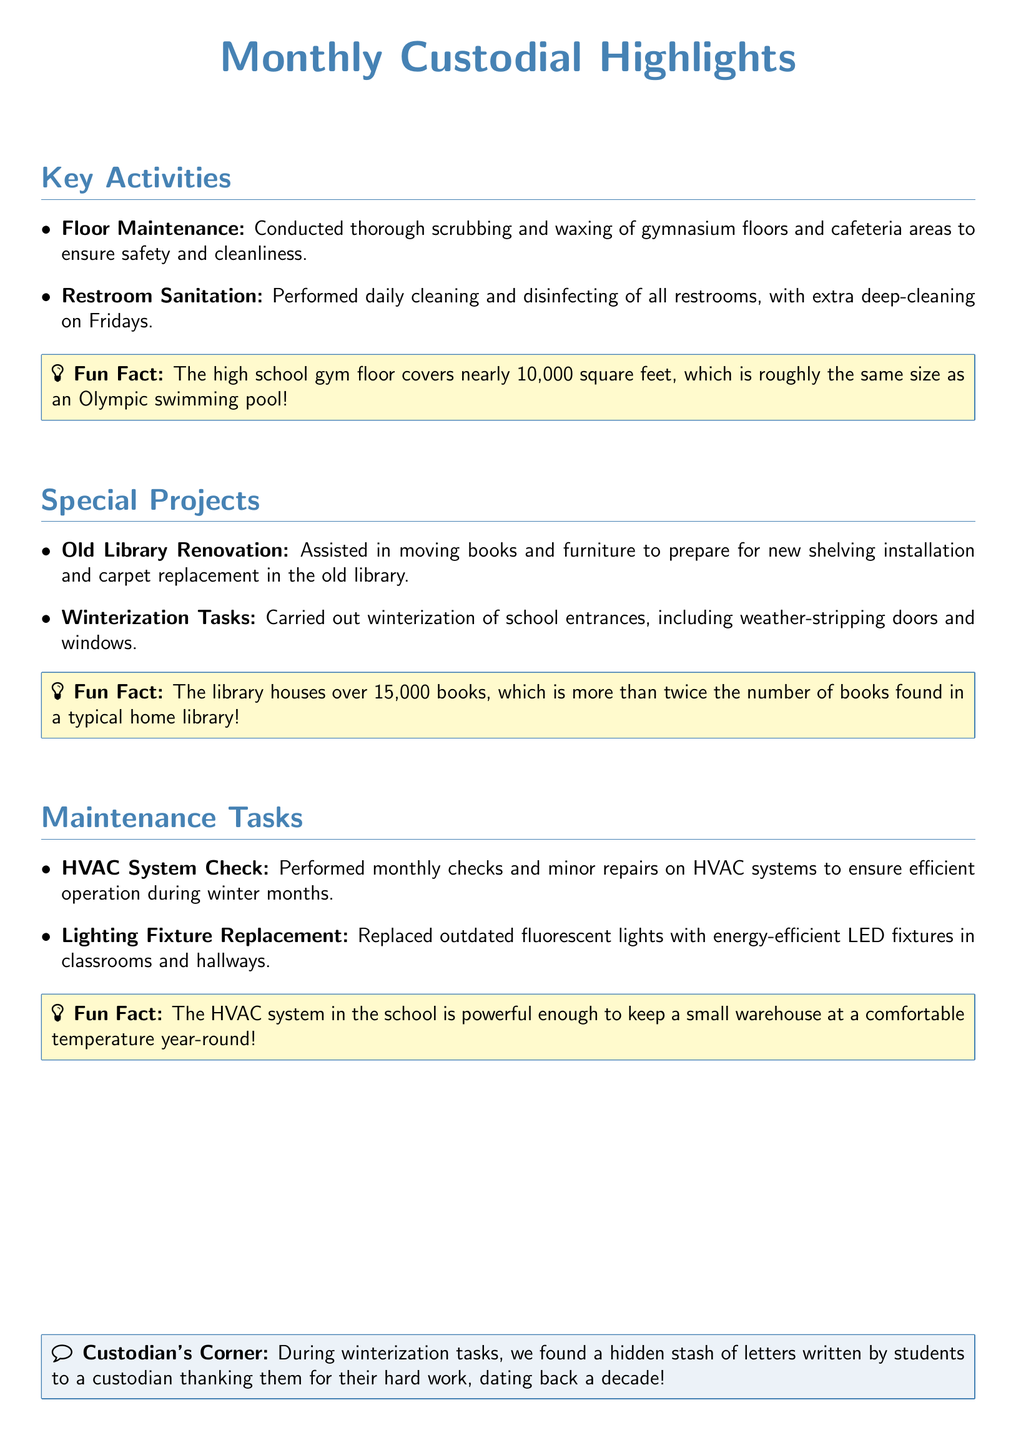What activity involves thorough scrubbing and waxing? The document mentions "Floor Maintenance" as an activity that includes thorough scrubbing and waxing of gymnasium floors and cafeteria areas.
Answer: Floor Maintenance How many square feet does the gym floor cover? The document states that the gym floor covers nearly 10,000 square feet.
Answer: 10,000 square feet What special project involved moving books? The "Old Library Renovation" is the special project that involved moving books and furniture to prepare for renovations.
Answer: Old Library Renovation How many books does the library house? The document indicates that the library houses over 15,000 books.
Answer: 15,000 books What system was checked for maintenance tasks? The HVAC System was checked as part of the maintenance tasks performed.
Answer: HVAC System What was replaced in classrooms and hallways? The document mentions that lighting fixtures were replaced with energy-efficient LED fixtures.
Answer: Lighting Fixture Replacement What did custodians find during winterization tasks? A hidden stash of letters written by students to a custodian was discovered during winterization tasks.
Answer: Hidden stash of letters What is the fun fact about the library? The trivia states that the library's collection is more than twice the number of books found in a typical home library.
Answer: More than twice the number of books in a typical home library What type of lighting was replaced? The document states that outdated fluorescent lights were replaced.
Answer: Outdated fluorescent lights 